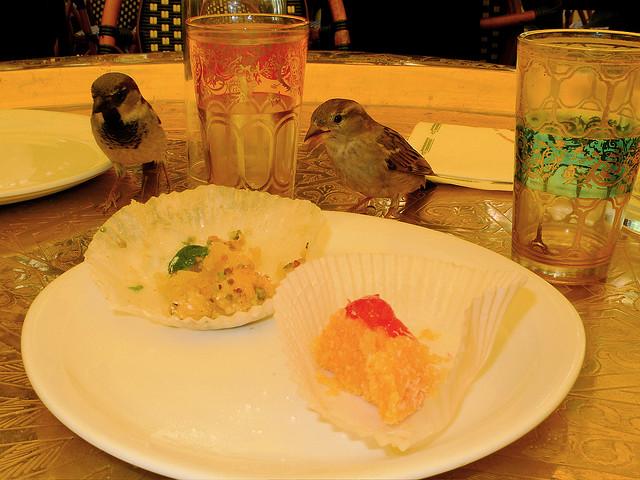How many glasses do you see?
Concise answer only. 2. Are the birds eating the treats at the moment?
Keep it brief. No. What colors are on each of the glasses?
Short answer required. Red and green. How many birds are on the table?
Concise answer only. 2. 